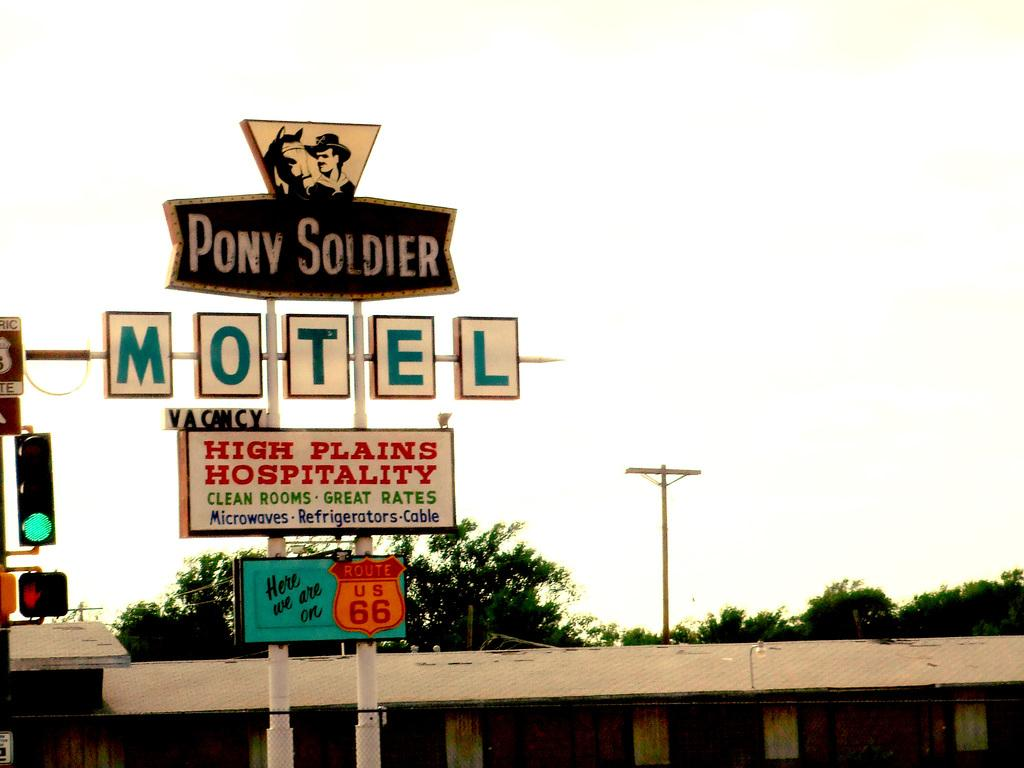<image>
Describe the image concisely. A sign for a motel which has the words Pony Soldier above it. 